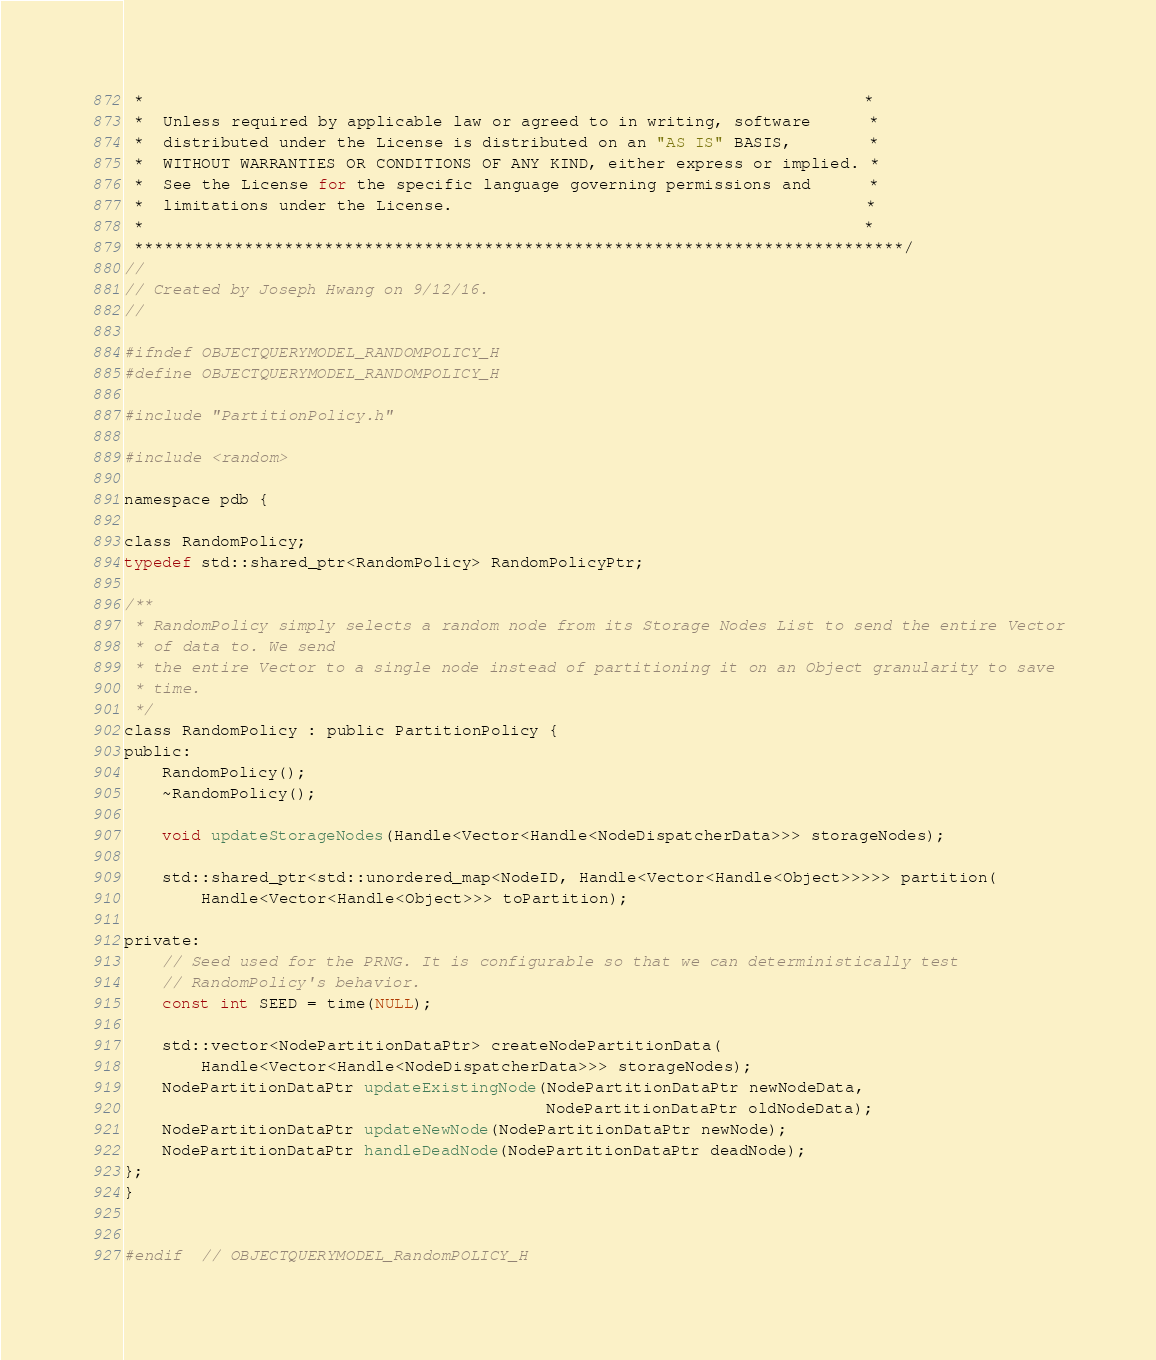<code> <loc_0><loc_0><loc_500><loc_500><_C_> *                                                                           *
 *  Unless required by applicable law or agreed to in writing, software      *
 *  distributed under the License is distributed on an "AS IS" BASIS,        *
 *  WITHOUT WARRANTIES OR CONDITIONS OF ANY KIND, either express or implied. *
 *  See the License for the specific language governing permissions and      *
 *  limitations under the License.                                           *
 *                                                                           *
 *****************************************************************************/
//
// Created by Joseph Hwang on 9/12/16.
//

#ifndef OBJECTQUERYMODEL_RANDOMPOLICY_H
#define OBJECTQUERYMODEL_RANDOMPOLICY_H

#include "PartitionPolicy.h"

#include <random>

namespace pdb {

class RandomPolicy;
typedef std::shared_ptr<RandomPolicy> RandomPolicyPtr;

/**
 * RandomPolicy simply selects a random node from its Storage Nodes List to send the entire Vector
 * of data to. We send
 * the entire Vector to a single node instead of partitioning it on an Object granularity to save
 * time.
 */
class RandomPolicy : public PartitionPolicy {
public:
    RandomPolicy();
    ~RandomPolicy();

    void updateStorageNodes(Handle<Vector<Handle<NodeDispatcherData>>> storageNodes);

    std::shared_ptr<std::unordered_map<NodeID, Handle<Vector<Handle<Object>>>>> partition(
        Handle<Vector<Handle<Object>>> toPartition);

private:
    // Seed used for the PRNG. It is configurable so that we can deterministically test
    // RandomPolicy's behavior.
    const int SEED = time(NULL);

    std::vector<NodePartitionDataPtr> createNodePartitionData(
        Handle<Vector<Handle<NodeDispatcherData>>> storageNodes);
    NodePartitionDataPtr updateExistingNode(NodePartitionDataPtr newNodeData,
                                            NodePartitionDataPtr oldNodeData);
    NodePartitionDataPtr updateNewNode(NodePartitionDataPtr newNode);
    NodePartitionDataPtr handleDeadNode(NodePartitionDataPtr deadNode);
};
}


#endif  // OBJECTQUERYMODEL_RandomPOLICY_H
</code> 